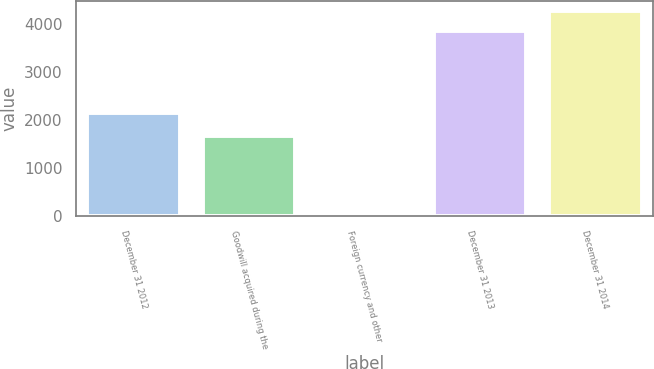Convert chart. <chart><loc_0><loc_0><loc_500><loc_500><bar_chart><fcel>December 31 2012<fcel>Goodwill acquired during the<fcel>Foreign currency and other<fcel>December 31 2013<fcel>December 31 2014<nl><fcel>2142<fcel>1669<fcel>33<fcel>3844<fcel>4259.3<nl></chart> 